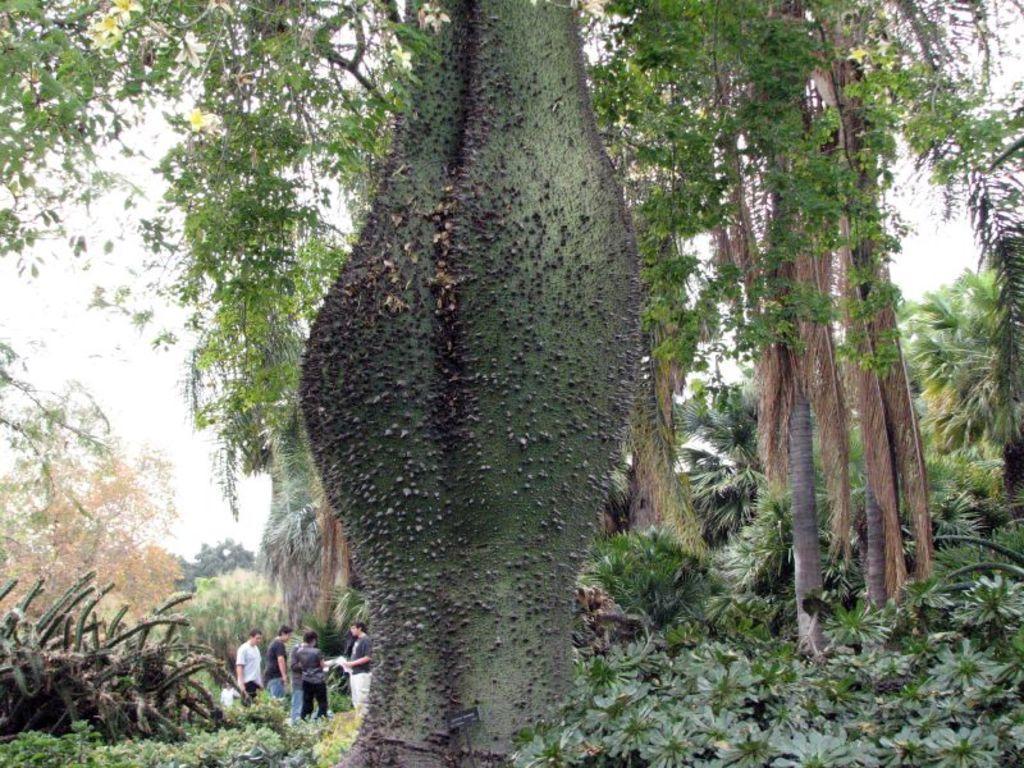Could you give a brief overview of what you see in this image? In this picture we can see trees, plants, flowers and a group of people standing and in the background we can see the sky. 